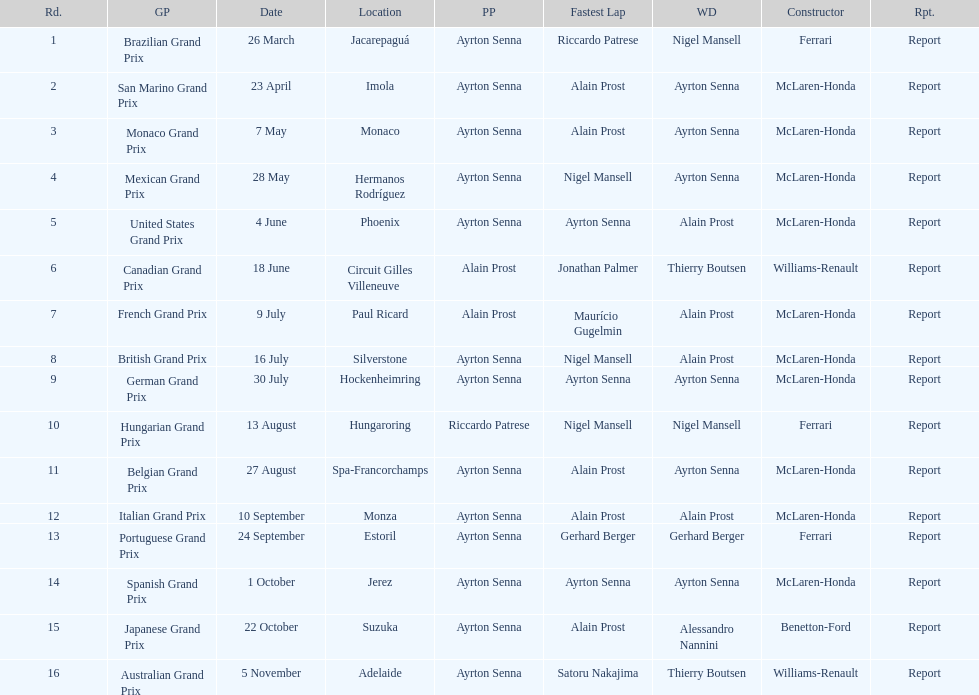Help me parse the entirety of this table. {'header': ['Rd.', 'GP', 'Date', 'Location', 'PP', 'Fastest Lap', 'WD', 'Constructor', 'Rpt.'], 'rows': [['1', 'Brazilian Grand Prix', '26 March', 'Jacarepaguá', 'Ayrton Senna', 'Riccardo Patrese', 'Nigel Mansell', 'Ferrari', 'Report'], ['2', 'San Marino Grand Prix', '23 April', 'Imola', 'Ayrton Senna', 'Alain Prost', 'Ayrton Senna', 'McLaren-Honda', 'Report'], ['3', 'Monaco Grand Prix', '7 May', 'Monaco', 'Ayrton Senna', 'Alain Prost', 'Ayrton Senna', 'McLaren-Honda', 'Report'], ['4', 'Mexican Grand Prix', '28 May', 'Hermanos Rodríguez', 'Ayrton Senna', 'Nigel Mansell', 'Ayrton Senna', 'McLaren-Honda', 'Report'], ['5', 'United States Grand Prix', '4 June', 'Phoenix', 'Ayrton Senna', 'Ayrton Senna', 'Alain Prost', 'McLaren-Honda', 'Report'], ['6', 'Canadian Grand Prix', '18 June', 'Circuit Gilles Villeneuve', 'Alain Prost', 'Jonathan Palmer', 'Thierry Boutsen', 'Williams-Renault', 'Report'], ['7', 'French Grand Prix', '9 July', 'Paul Ricard', 'Alain Prost', 'Maurício Gugelmin', 'Alain Prost', 'McLaren-Honda', 'Report'], ['8', 'British Grand Prix', '16 July', 'Silverstone', 'Ayrton Senna', 'Nigel Mansell', 'Alain Prost', 'McLaren-Honda', 'Report'], ['9', 'German Grand Prix', '30 July', 'Hockenheimring', 'Ayrton Senna', 'Ayrton Senna', 'Ayrton Senna', 'McLaren-Honda', 'Report'], ['10', 'Hungarian Grand Prix', '13 August', 'Hungaroring', 'Riccardo Patrese', 'Nigel Mansell', 'Nigel Mansell', 'Ferrari', 'Report'], ['11', 'Belgian Grand Prix', '27 August', 'Spa-Francorchamps', 'Ayrton Senna', 'Alain Prost', 'Ayrton Senna', 'McLaren-Honda', 'Report'], ['12', 'Italian Grand Prix', '10 September', 'Monza', 'Ayrton Senna', 'Alain Prost', 'Alain Prost', 'McLaren-Honda', 'Report'], ['13', 'Portuguese Grand Prix', '24 September', 'Estoril', 'Ayrton Senna', 'Gerhard Berger', 'Gerhard Berger', 'Ferrari', 'Report'], ['14', 'Spanish Grand Prix', '1 October', 'Jerez', 'Ayrton Senna', 'Ayrton Senna', 'Ayrton Senna', 'McLaren-Honda', 'Report'], ['15', 'Japanese Grand Prix', '22 October', 'Suzuka', 'Ayrton Senna', 'Alain Prost', 'Alessandro Nannini', 'Benetton-Ford', 'Report'], ['16', 'Australian Grand Prix', '5 November', 'Adelaide', 'Ayrton Senna', 'Satoru Nakajima', 'Thierry Boutsen', 'Williams-Renault', 'Report']]} Who had the fastest lap at the german grand prix? Ayrton Senna. 